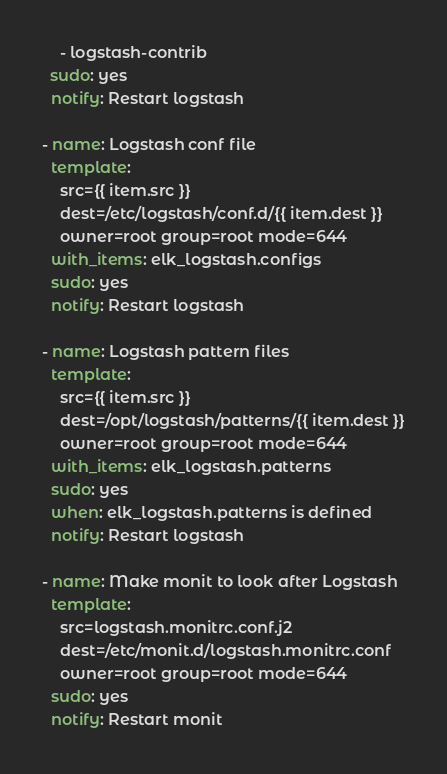Convert code to text. <code><loc_0><loc_0><loc_500><loc_500><_YAML_>    - logstash-contrib
  sudo: yes
  notify: Restart logstash

- name: Logstash conf file
  template:
    src={{ item.src }}
    dest=/etc/logstash/conf.d/{{ item.dest }}
    owner=root group=root mode=644
  with_items: elk_logstash.configs
  sudo: yes
  notify: Restart logstash

- name: Logstash pattern files
  template:
    src={{ item.src }}
    dest=/opt/logstash/patterns/{{ item.dest }}
    owner=root group=root mode=644
  with_items: elk_logstash.patterns
  sudo: yes
  when: elk_logstash.patterns is defined
  notify: Restart logstash

- name: Make monit to look after Logstash
  template:
    src=logstash.monitrc.conf.j2
    dest=/etc/monit.d/logstash.monitrc.conf
    owner=root group=root mode=644
  sudo: yes
  notify: Restart monit
</code> 